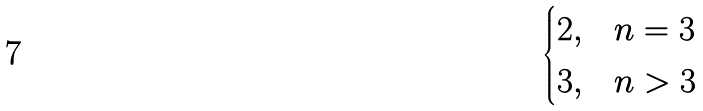<formula> <loc_0><loc_0><loc_500><loc_500>\begin{cases} 2 , & n = 3 \\ 3 , & n > 3 \end{cases}</formula> 